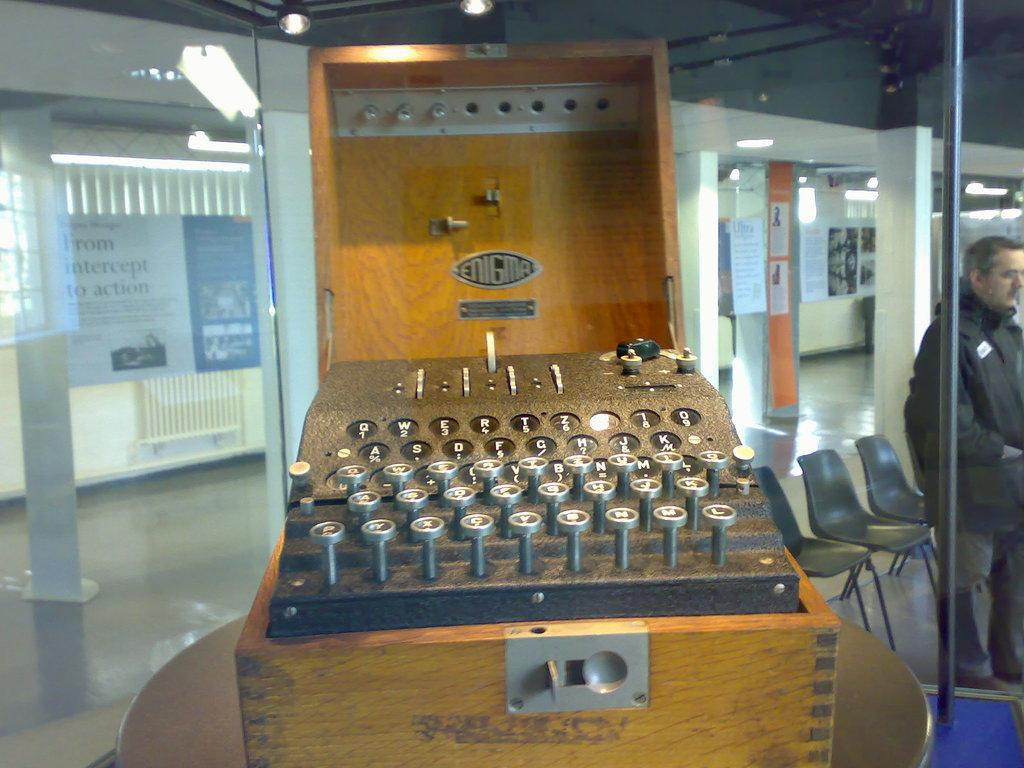<image>
Summarize the visual content of the image. A very old vintage typewriter made my Enigma behind a glass display case. 